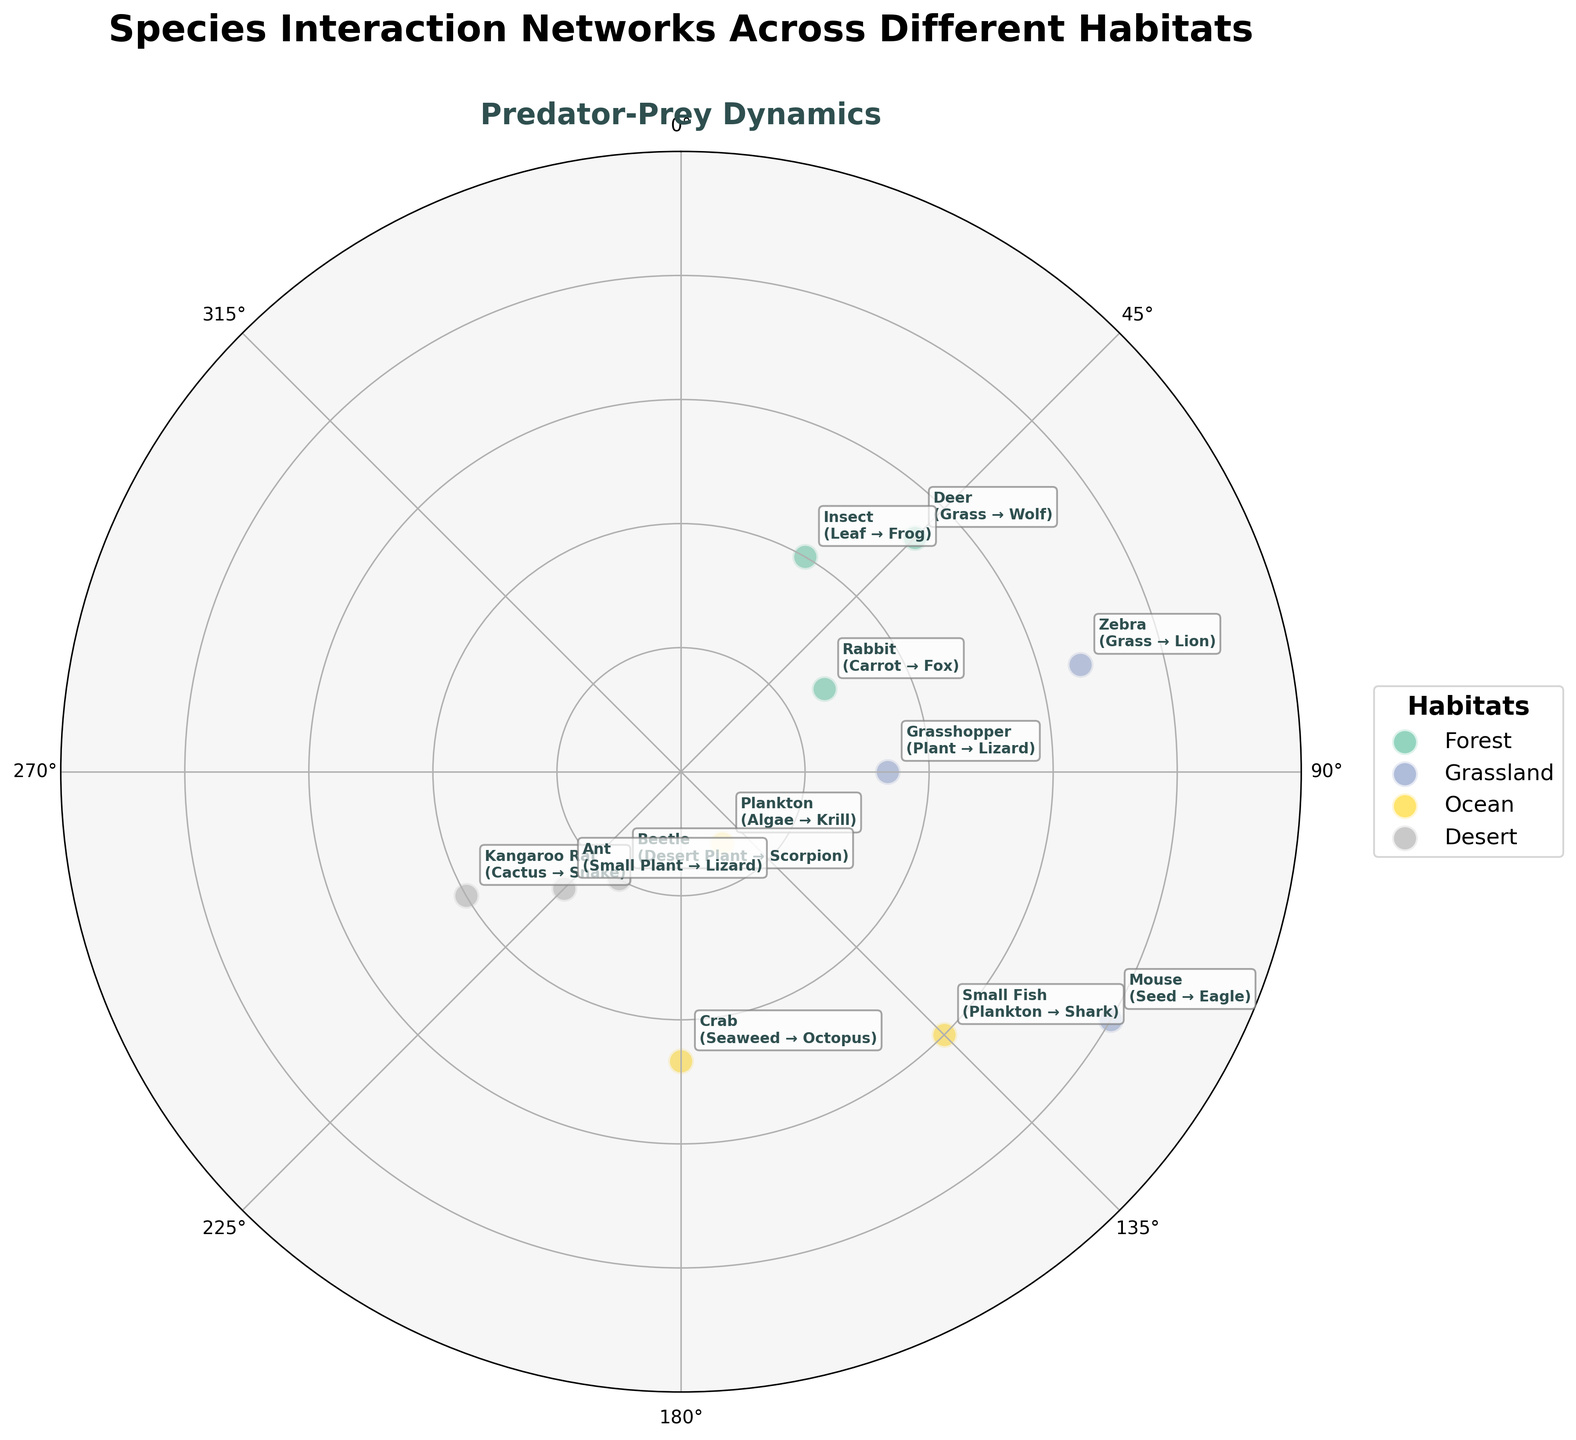How many habitats are represented in the chart? The legend indicates different colors for habitats. By counting the entries in the legend, we see that there are four habitats presented.
Answer: 4 What species in the Grassland is associated with the smallest distance from the center? The species in the Grassland are Zebra, Mouse, and Grasshopper with distances of 10, 12, and 5 units respectively. The Grasshopper is the closest to the center.
Answer: Grasshopper Which habitat features the species interaction involving a shark? Locate the "Shark" in the annotated text and find its color. The Shark interacts with the Small Fish in the Ocean habitat, indicated by the color in the legend.
Answer: Ocean Comparing 'Crab' and 'Kangaroo Rat,' which species is farther from the center? The Crab has a distance of 7, and the Kangaroo Rat has a distance of 6. Thus, Crab is farther from the center.
Answer: Crab What is the angle range for species in the Desert habitat? Identify species in the Desert and their angles: Kangaroo Rat (240°), Beetle (210°), and Ant (225°). The range is from 210° to 240°.
Answer: 210° - 240° Which habitat has the species with the smallest distance from the center? Find the smallest distance value in the chart, which is 2 (Plankton). The habitat for Plankton is Ocean.
Answer: Ocean What is the common prey for the species in the habitat with the angle closest to 180 degrees? The species closest to 180 degrees is Crab in the Ocean habitat, with the prey being Seaweed.
Answer: Crab How many species are there in the Forest habitat? By counting the species annotations under the Forest habitat color in the legend, we see that there are three species: Deer, Rabbit, and Insect.
Answer: 3 Compare the distances of species in Forest and Desert habitats. Which habitat has the species most distant from the center? Find the largest distance value for species in Forest and Desert. Forest has maximum 8 (Deer), whereas Desert has maximum 6 (Kangaroo Rat). Deer (8) in Forest is most distant from the center.
Answer: Forest 